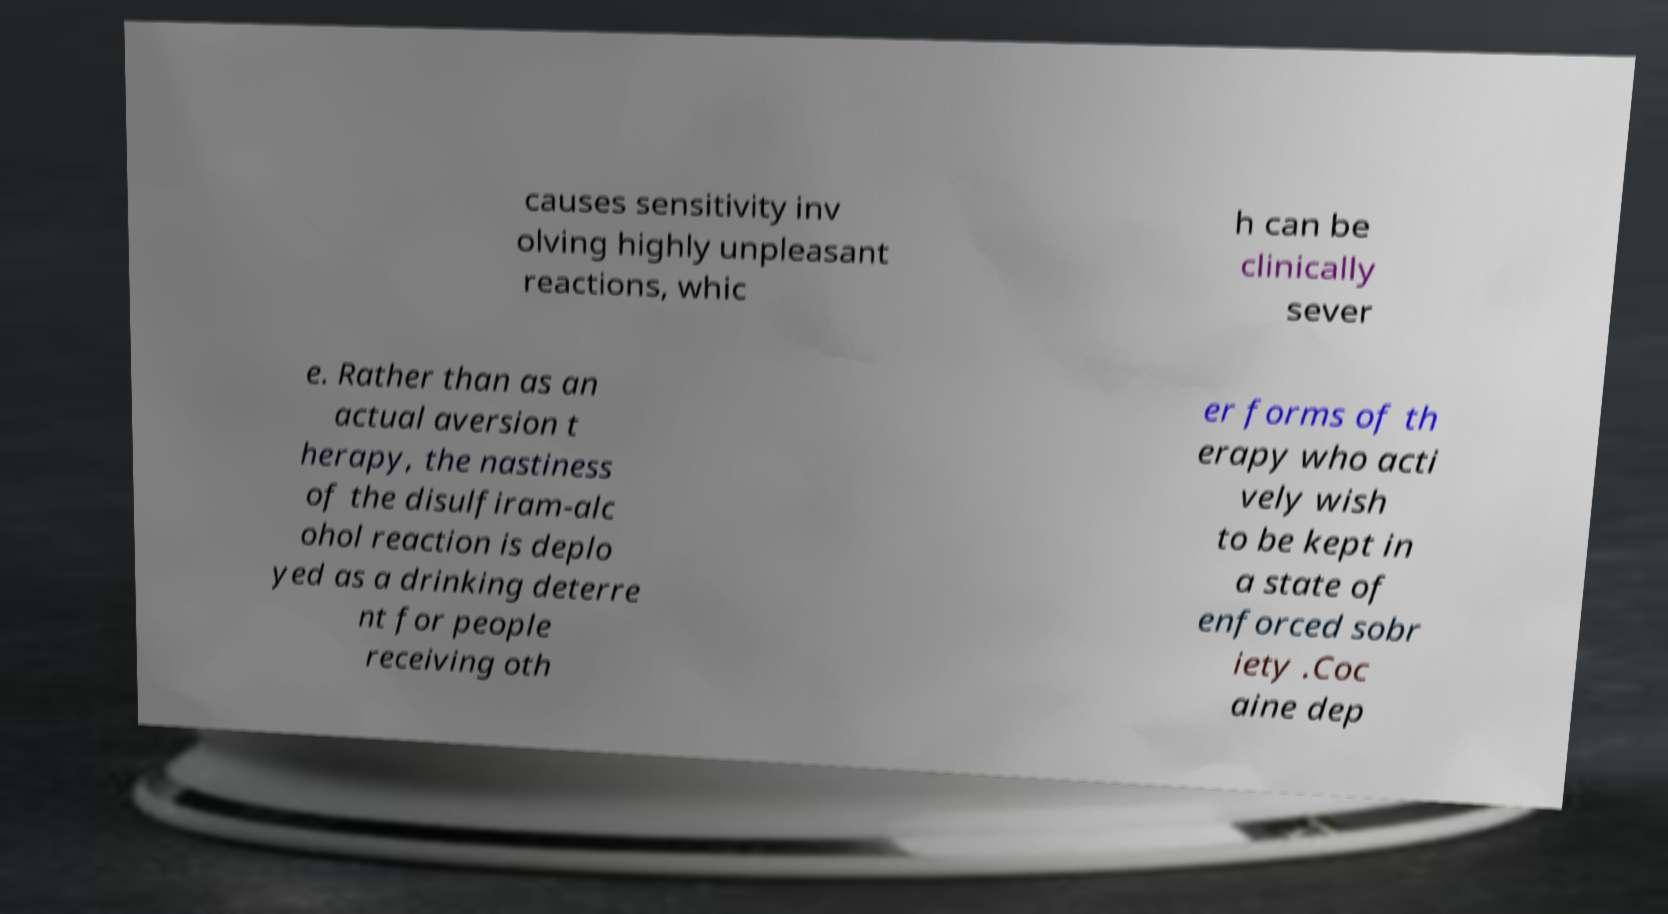Can you accurately transcribe the text from the provided image for me? causes sensitivity inv olving highly unpleasant reactions, whic h can be clinically sever e. Rather than as an actual aversion t herapy, the nastiness of the disulfiram-alc ohol reaction is deplo yed as a drinking deterre nt for people receiving oth er forms of th erapy who acti vely wish to be kept in a state of enforced sobr iety .Coc aine dep 